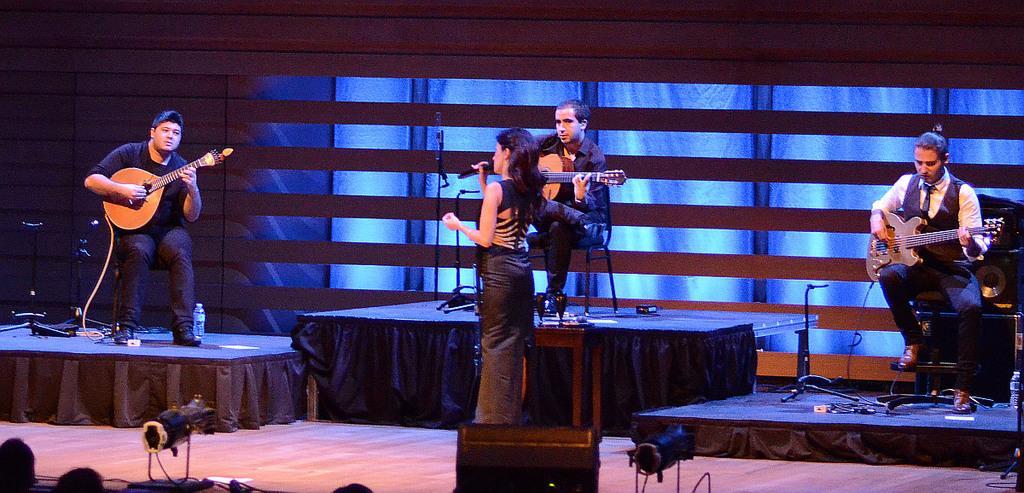How would you summarize this image in a sentence or two? Here we can see a group of persons are siting and playing the guitar, and here a woman is standing, and holding a microphone in her hand. 